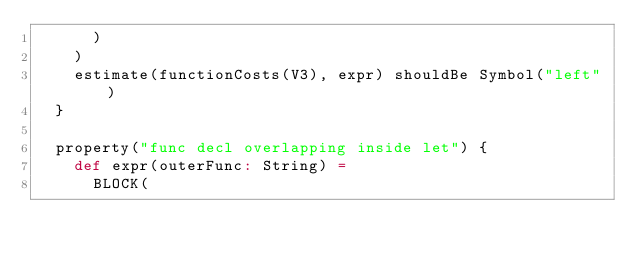Convert code to text. <code><loc_0><loc_0><loc_500><loc_500><_Scala_>      )
    )
    estimate(functionCosts(V3), expr) shouldBe Symbol("left")
  }

  property("func decl overlapping inside let") {
    def expr(outerFunc: String) =
      BLOCK(</code> 